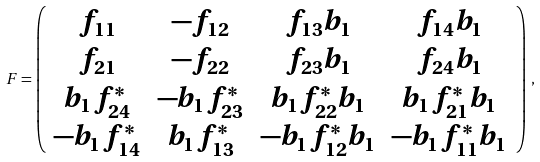Convert formula to latex. <formula><loc_0><loc_0><loc_500><loc_500>F = \left ( \begin{array} { c c c c } f _ { 1 1 } & - f _ { 1 2 } & f _ { 1 3 } b _ { 1 } & f _ { 1 4 } b _ { 1 } \\ f _ { 2 1 } & - f _ { 2 2 } & f _ { 2 3 } b _ { 1 } & f _ { 2 4 } b _ { 1 } \\ b _ { 1 } f _ { 2 4 } ^ { * } & - b _ { 1 } f _ { 2 3 } ^ { * } & b _ { 1 } f _ { 2 2 } ^ { * } b _ { 1 } & b _ { 1 } f _ { 2 1 } ^ { * } b _ { 1 } \\ - b _ { 1 } f _ { 1 4 } ^ { * } & b _ { 1 } f _ { 1 3 } ^ { * } & - b _ { 1 } f _ { 1 2 } ^ { * } b _ { 1 } & - b _ { 1 } f _ { 1 1 } ^ { * } b _ { 1 } \end{array} \right ) \, ,</formula> 